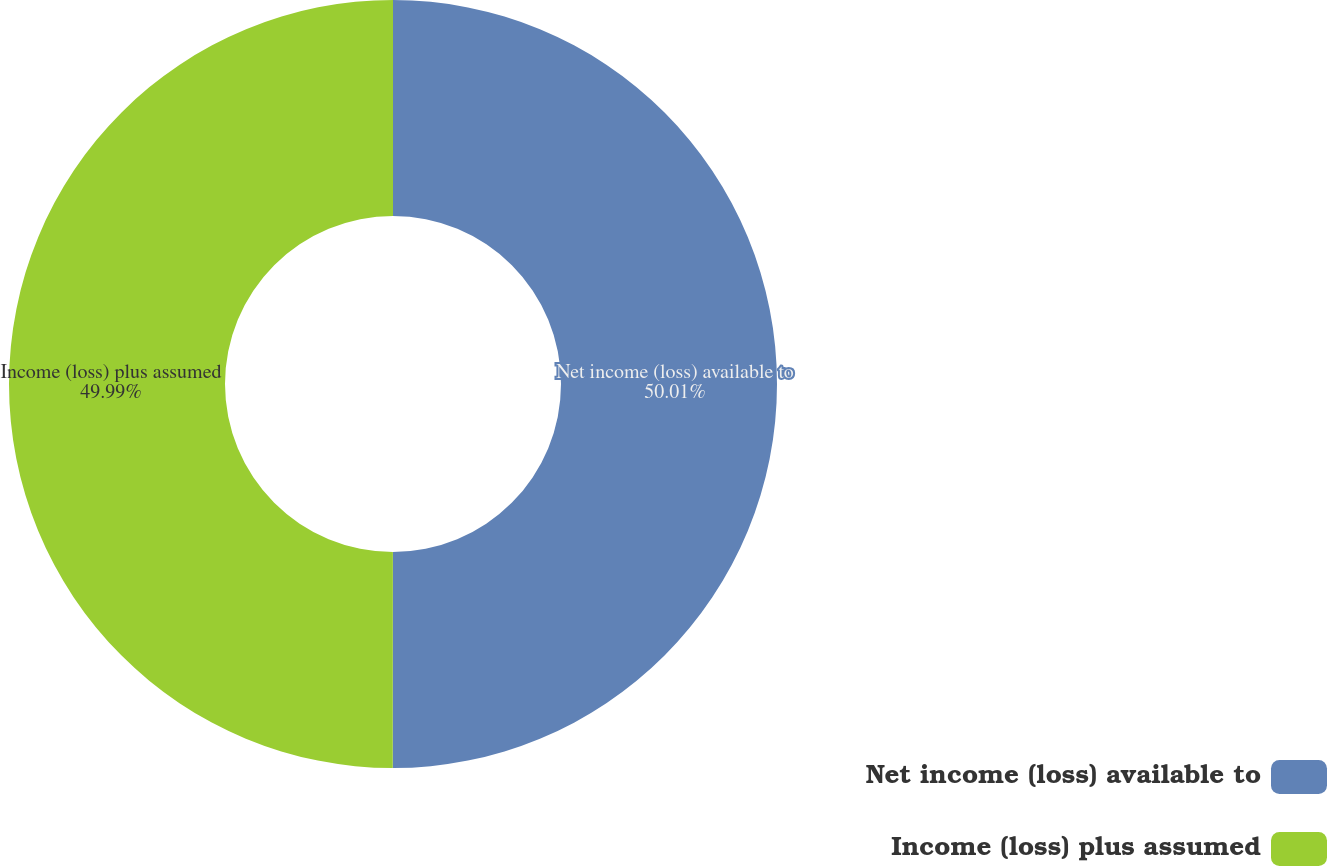Convert chart. <chart><loc_0><loc_0><loc_500><loc_500><pie_chart><fcel>Net income (loss) available to<fcel>Income (loss) plus assumed<nl><fcel>50.01%<fcel>49.99%<nl></chart> 